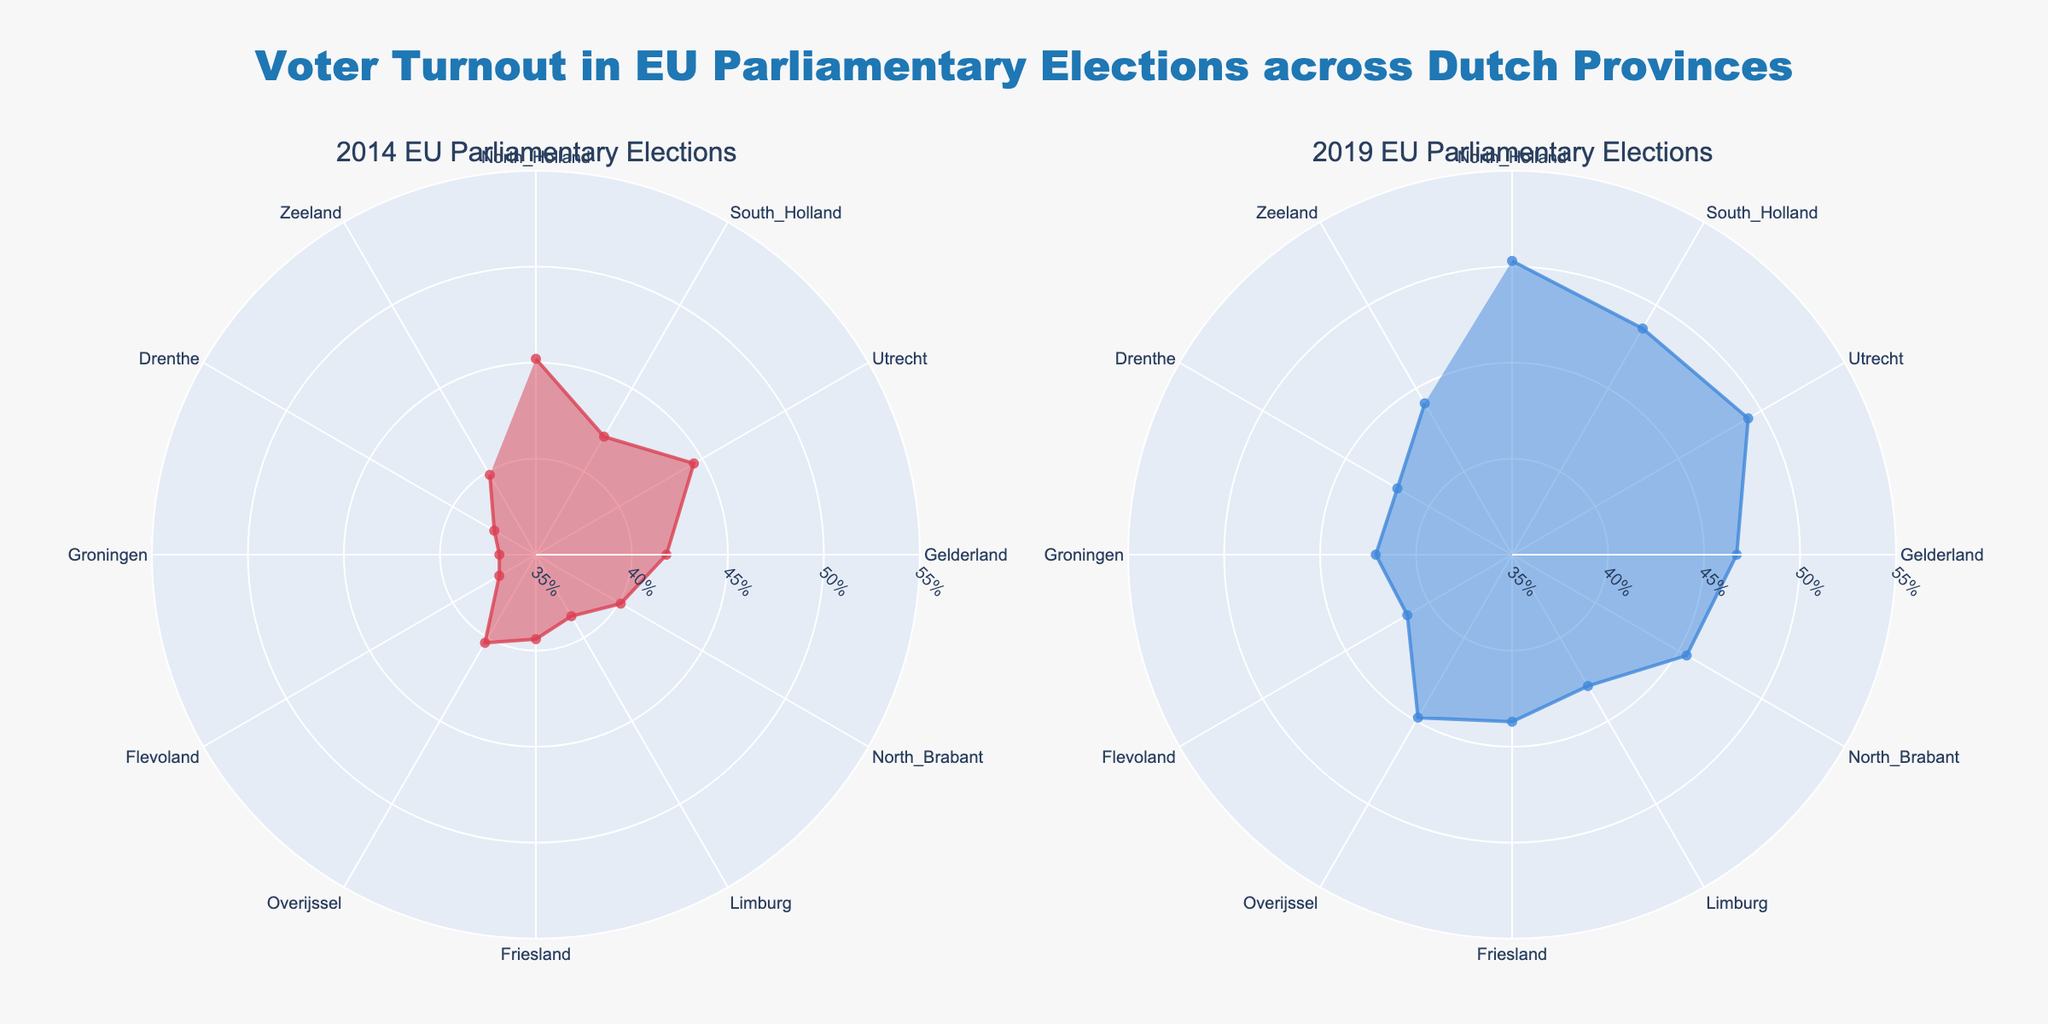What's the title of the figure? Look at the top of the figure where the title is usually placed. The title is often a summary of what the figure represents.
Answer: "Voter Turnout in EU Parliamentary Elections across Dutch Provinces" How many provinces are displayed in the figure? Count the number of unique provinces listed around the outer ring of the rose chart. There are markers for each province.
Answer: 12 Which province had the highest voter turnout in 2014? Compare the lengths of the radial markers in the 2014 subplot for each province. The longest radial marker corresponds to the highest voter turnout.
Answer: North_Holland Did voter turnout increase or decrease in North Brabant from 2014 to 2019? Compare the length of the radial markers for North Brabant between the 2014 and 2019 subplots. The increase or decrease is indicated by whether the 2019 marker is longer or shorter than the 2014 marker.
Answer: Increase What is the difference in voter turnout between Groningen and Utrecht in 2019? Look at the lengths of the radial markers in the 2019 subplot for Groningen and Utrecht. Subtract the value for Groningen from the value for Utrecht.
Answer: 49.2% - 42.1% = 7.1% Which province had the lowest voter turnout in 2019? Compare the lengths of the radial markers in the 2019 subplot for each province. The shortest radial marker corresponds to the lowest voter turnout.
Answer: Flevoland How did the overall voter turnout trend change from 2014 to 2019 across all provinces? Observe the overall pattern of the radial markers in both subplots. If most markers in 2019 are longer than those in 2014, the trend is an increase, otherwise, it's a decrease.
Answer: Increase What was the average voter turnout across all provinces in 2014? Sum all the voter turnout percentages for 2014 and divide by the number of provinces.
Answer: (45.2 + 42.1 + 44.5 + 41.8 + 40.1 + 38.7 + 39.4 + 40.3 + 37.2 + 36.9 + 37.5 + 39.8) / 12 = 40.58% Compare the voter turnout for Friesland between 2014 and 2019. Which year had higher turnout and by how much? Look at the lengths of the radial markers for Friesland in both the 2014 and 2019 subplots. Subtract the 2014 turnout from the 2019 turnout to find the difference.
Answer: 2019 had a higher turnout by 4.3% 